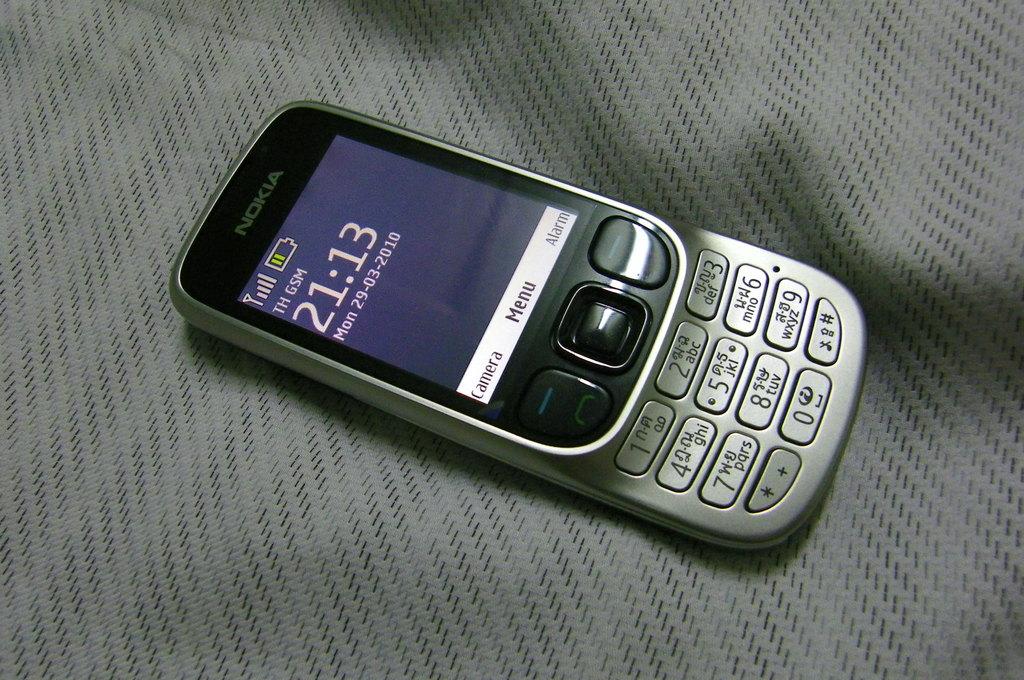What time is it on the phone?
Offer a terse response. 21:13. What is the brand of this phone?
Your answer should be compact. Nokia. 